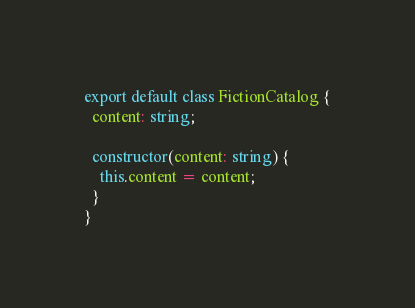<code> <loc_0><loc_0><loc_500><loc_500><_TypeScript_>export default class FictionCatalog {
  content: string;

  constructor(content: string) {
    this.content = content;
  }
}
</code> 